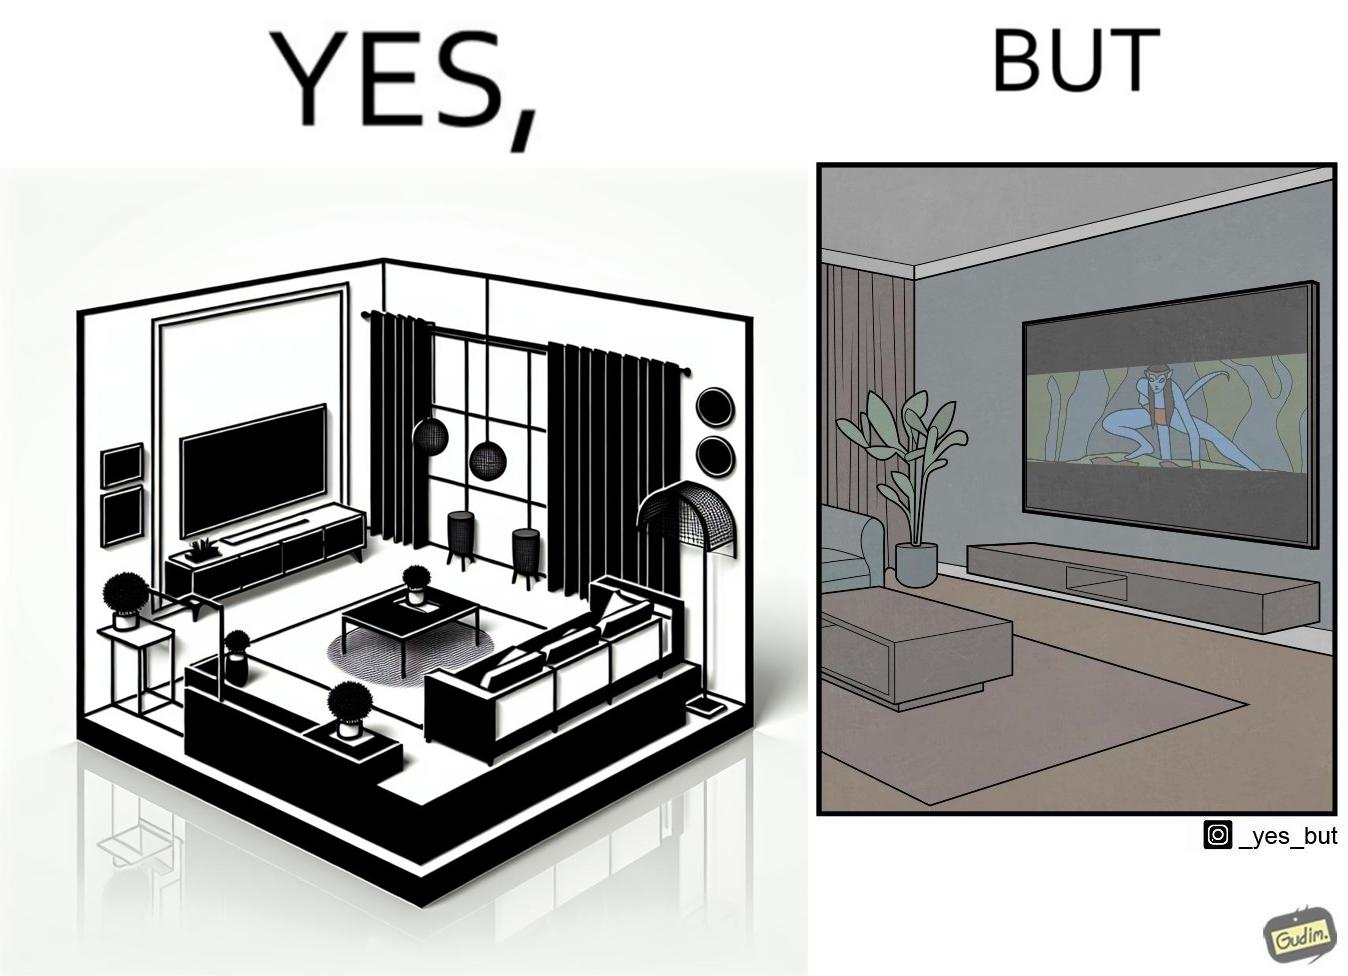Is this image satirical or non-satirical? Yes, this image is satirical. 